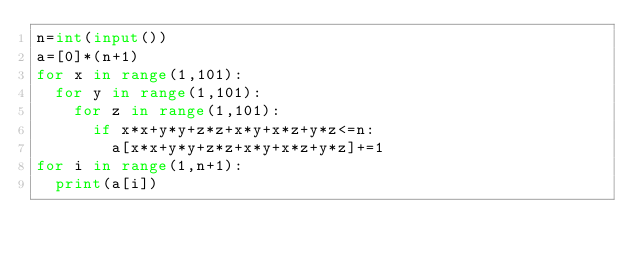<code> <loc_0><loc_0><loc_500><loc_500><_Python_>n=int(input())
a=[0]*(n+1)
for x in range(1,101):
  for y in range(1,101):
    for z in range(1,101):
      if x*x+y*y+z*z+x*y+x*z+y*z<=n:
        a[x*x+y*y+z*z+x*y+x*z+y*z]+=1
for i in range(1,n+1):
  print(a[i])</code> 